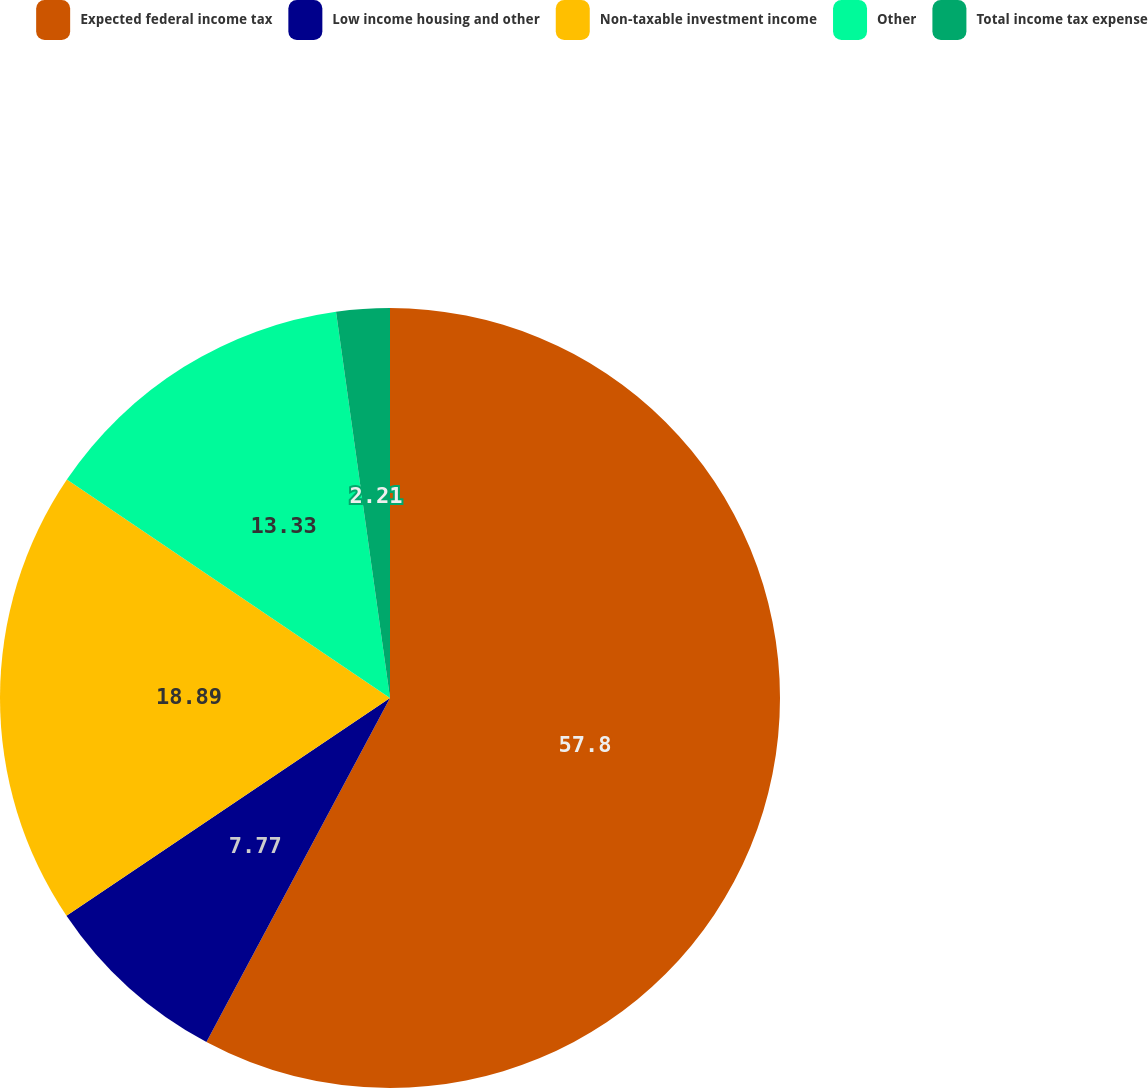Convert chart. <chart><loc_0><loc_0><loc_500><loc_500><pie_chart><fcel>Expected federal income tax<fcel>Low income housing and other<fcel>Non-taxable investment income<fcel>Other<fcel>Total income tax expense<nl><fcel>57.8%<fcel>7.77%<fcel>18.89%<fcel>13.33%<fcel>2.21%<nl></chart> 